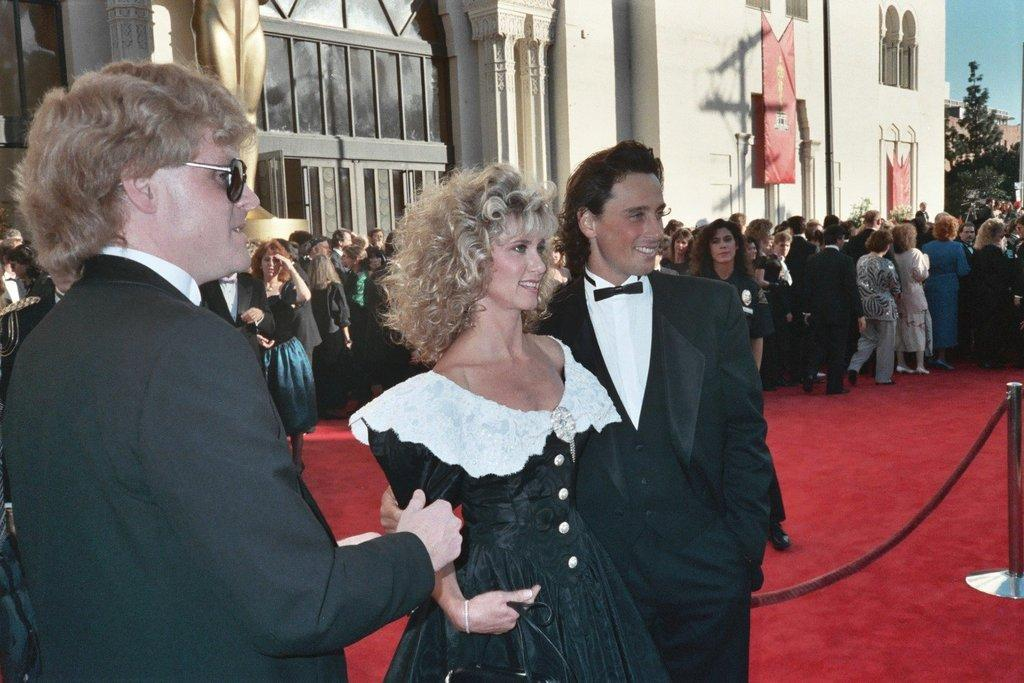What is happening in the image? There are people standing in the image. What can be seen between the people and the building in the background? There is a stainless steel barrier in the image. What is visible on the building in the background? There are windows on the building. What type of vegetation is present in the background of the image? Trees are present in the background of the image. What is visible above the people and the barrier? The sky is visible in the image. How many frogs are sitting on the windowsill of the building in the image? There are no frogs visible in the image, and therefore no frogs can be seen sitting on the windowsill. 